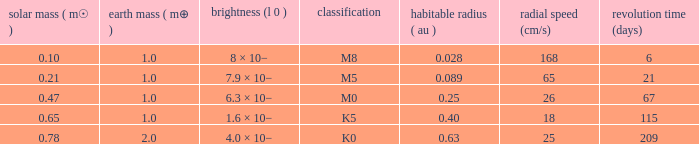What is the smallest period (days) to have a planetary mass of 1, a stellar mass greater than 0.21 and of the type M0? 67.0. 